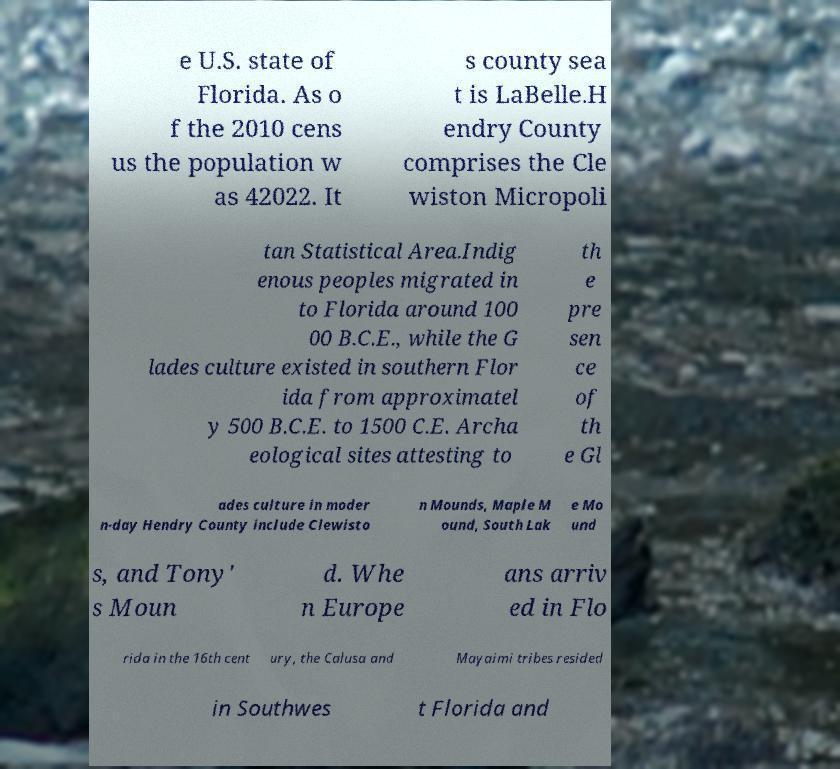Please identify and transcribe the text found in this image. e U.S. state of Florida. As o f the 2010 cens us the population w as 42022. It s county sea t is LaBelle.H endry County comprises the Cle wiston Micropoli tan Statistical Area.Indig enous peoples migrated in to Florida around 100 00 B.C.E., while the G lades culture existed in southern Flor ida from approximatel y 500 B.C.E. to 1500 C.E. Archa eological sites attesting to th e pre sen ce of th e Gl ades culture in moder n-day Hendry County include Clewisto n Mounds, Maple M ound, South Lak e Mo und s, and Tony' s Moun d. Whe n Europe ans arriv ed in Flo rida in the 16th cent ury, the Calusa and Mayaimi tribes resided in Southwes t Florida and 